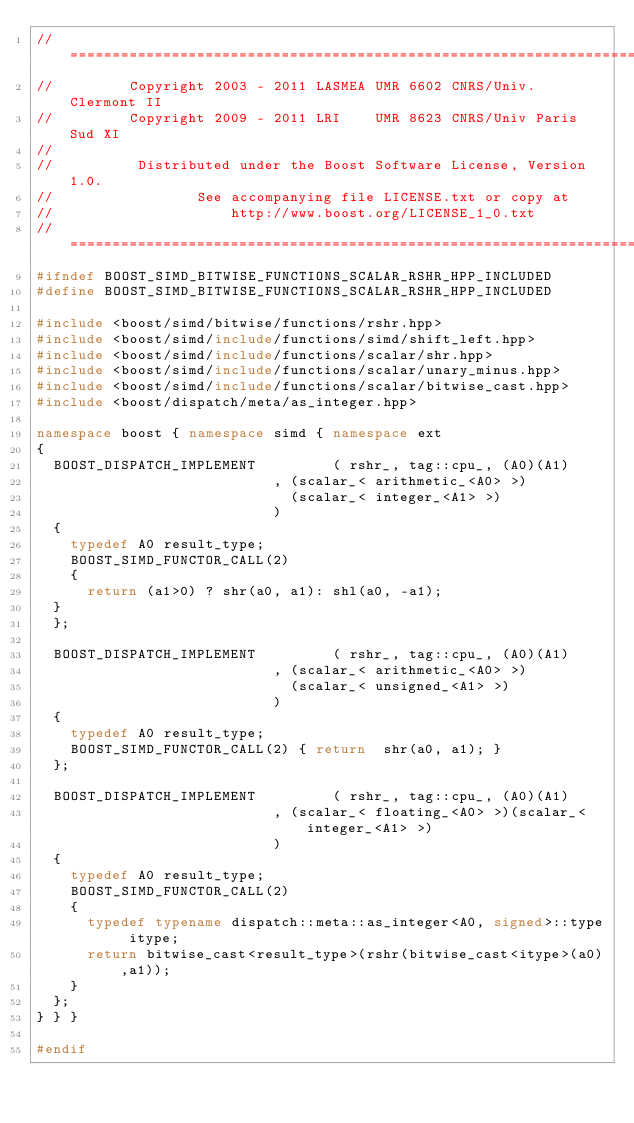<code> <loc_0><loc_0><loc_500><loc_500><_C++_>//==============================================================================
//         Copyright 2003 - 2011 LASMEA UMR 6602 CNRS/Univ. Clermont II
//         Copyright 2009 - 2011 LRI    UMR 8623 CNRS/Univ Paris Sud XI
//
//          Distributed under the Boost Software License, Version 1.0.
//                 See accompanying file LICENSE.txt or copy at
//                     http://www.boost.org/LICENSE_1_0.txt
//==============================================================================
#ifndef BOOST_SIMD_BITWISE_FUNCTIONS_SCALAR_RSHR_HPP_INCLUDED
#define BOOST_SIMD_BITWISE_FUNCTIONS_SCALAR_RSHR_HPP_INCLUDED

#include <boost/simd/bitwise/functions/rshr.hpp>
#include <boost/simd/include/functions/simd/shift_left.hpp>
#include <boost/simd/include/functions/scalar/shr.hpp>
#include <boost/simd/include/functions/scalar/unary_minus.hpp>
#include <boost/simd/include/functions/scalar/bitwise_cast.hpp>
#include <boost/dispatch/meta/as_integer.hpp>

namespace boost { namespace simd { namespace ext
{
  BOOST_DISPATCH_IMPLEMENT         ( rshr_, tag::cpu_, (A0)(A1)
                            , (scalar_< arithmetic_<A0> >)
                              (scalar_< integer_<A1> >)
                            )
  {
    typedef A0 result_type;
    BOOST_SIMD_FUNCTOR_CALL(2)
    {
      return (a1>0) ? shr(a0, a1): shl(a0, -a1);
  }
  };

  BOOST_DISPATCH_IMPLEMENT         ( rshr_, tag::cpu_, (A0)(A1)
                            , (scalar_< arithmetic_<A0> >)
                              (scalar_< unsigned_<A1> >)
                            )
  {
    typedef A0 result_type;
    BOOST_SIMD_FUNCTOR_CALL(2) { return  shr(a0, a1); }
  };

  BOOST_DISPATCH_IMPLEMENT         ( rshr_, tag::cpu_, (A0)(A1)
                            , (scalar_< floating_<A0> >)(scalar_< integer_<A1> >)
                            )
  {
    typedef A0 result_type;
    BOOST_SIMD_FUNCTOR_CALL(2)
    {
      typedef typename dispatch::meta::as_integer<A0, signed>::type itype;
      return bitwise_cast<result_type>(rshr(bitwise_cast<itype>(a0),a1));
    }
  };
} } }

#endif
</code> 